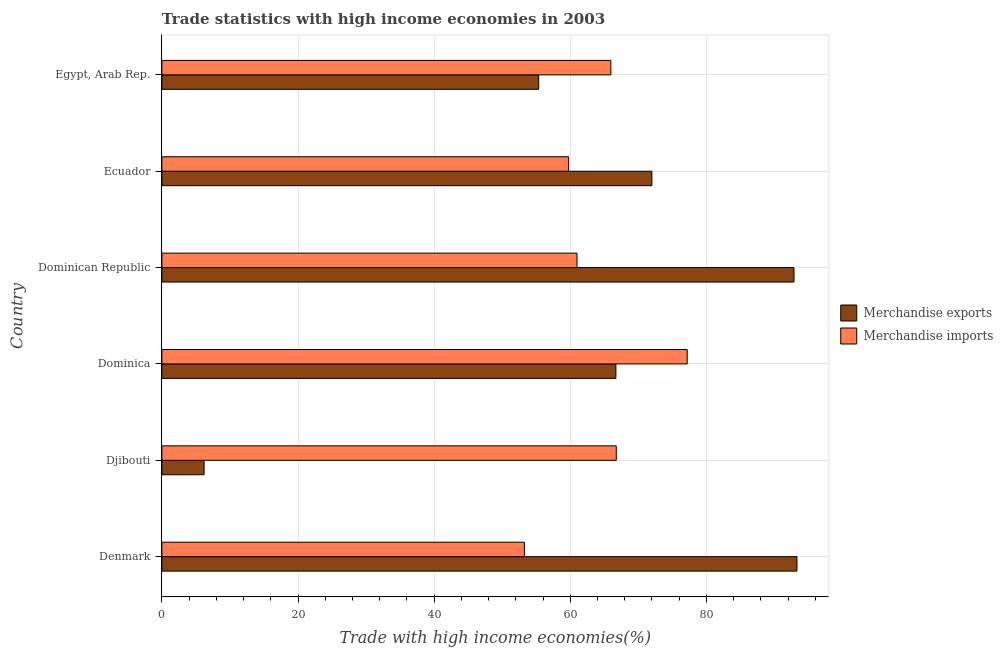How many different coloured bars are there?
Provide a succinct answer. 2. How many groups of bars are there?
Provide a short and direct response. 6. Are the number of bars on each tick of the Y-axis equal?
Keep it short and to the point. Yes. How many bars are there on the 4th tick from the top?
Offer a terse response. 2. What is the label of the 1st group of bars from the top?
Your answer should be compact. Egypt, Arab Rep. What is the merchandise exports in Denmark?
Offer a terse response. 93.31. Across all countries, what is the maximum merchandise exports?
Ensure brevity in your answer.  93.31. Across all countries, what is the minimum merchandise imports?
Offer a terse response. 53.26. In which country was the merchandise imports minimum?
Provide a short and direct response. Denmark. What is the total merchandise exports in the graph?
Provide a succinct answer. 386.44. What is the difference between the merchandise exports in Djibouti and that in Egypt, Arab Rep.?
Give a very brief answer. -49.16. What is the difference between the merchandise imports in Ecuador and the merchandise exports in Denmark?
Ensure brevity in your answer.  -33.55. What is the average merchandise imports per country?
Give a very brief answer. 63.98. What is the difference between the merchandise imports and merchandise exports in Dominica?
Ensure brevity in your answer.  10.48. In how many countries, is the merchandise exports greater than 68 %?
Offer a terse response. 3. What is the ratio of the merchandise imports in Djibouti to that in Ecuador?
Your response must be concise. 1.12. Is the merchandise exports in Dominican Republic less than that in Egypt, Arab Rep.?
Offer a terse response. No. Is the difference between the merchandise exports in Dominica and Dominican Republic greater than the difference between the merchandise imports in Dominica and Dominican Republic?
Provide a succinct answer. No. What is the difference between the highest and the second highest merchandise exports?
Give a very brief answer. 0.44. What is the difference between the highest and the lowest merchandise imports?
Give a very brief answer. 23.92. In how many countries, is the merchandise imports greater than the average merchandise imports taken over all countries?
Your response must be concise. 3. Is the sum of the merchandise imports in Dominican Republic and Ecuador greater than the maximum merchandise exports across all countries?
Your answer should be compact. Yes. What does the 2nd bar from the top in Ecuador represents?
Give a very brief answer. Merchandise exports. How many bars are there?
Your answer should be very brief. 12. How many countries are there in the graph?
Provide a short and direct response. 6. What is the difference between two consecutive major ticks on the X-axis?
Provide a succinct answer. 20. Does the graph contain any zero values?
Offer a very short reply. No. How are the legend labels stacked?
Give a very brief answer. Vertical. What is the title of the graph?
Your answer should be compact. Trade statistics with high income economies in 2003. Does "State government" appear as one of the legend labels in the graph?
Your answer should be very brief. No. What is the label or title of the X-axis?
Your answer should be compact. Trade with high income economies(%). What is the Trade with high income economies(%) in Merchandise exports in Denmark?
Give a very brief answer. 93.31. What is the Trade with high income economies(%) in Merchandise imports in Denmark?
Your response must be concise. 53.26. What is the Trade with high income economies(%) in Merchandise exports in Djibouti?
Provide a short and direct response. 6.2. What is the Trade with high income economies(%) in Merchandise imports in Djibouti?
Your answer should be very brief. 66.76. What is the Trade with high income economies(%) in Merchandise exports in Dominica?
Give a very brief answer. 66.7. What is the Trade with high income economies(%) in Merchandise imports in Dominica?
Your answer should be very brief. 77.18. What is the Trade with high income economies(%) of Merchandise exports in Dominican Republic?
Ensure brevity in your answer.  92.87. What is the Trade with high income economies(%) in Merchandise imports in Dominican Republic?
Provide a succinct answer. 60.99. What is the Trade with high income economies(%) of Merchandise exports in Ecuador?
Your answer should be compact. 71.99. What is the Trade with high income economies(%) in Merchandise imports in Ecuador?
Make the answer very short. 59.76. What is the Trade with high income economies(%) in Merchandise exports in Egypt, Arab Rep.?
Your response must be concise. 55.36. What is the Trade with high income economies(%) in Merchandise imports in Egypt, Arab Rep.?
Offer a terse response. 65.96. Across all countries, what is the maximum Trade with high income economies(%) in Merchandise exports?
Provide a succinct answer. 93.31. Across all countries, what is the maximum Trade with high income economies(%) of Merchandise imports?
Offer a very short reply. 77.18. Across all countries, what is the minimum Trade with high income economies(%) in Merchandise exports?
Ensure brevity in your answer.  6.2. Across all countries, what is the minimum Trade with high income economies(%) in Merchandise imports?
Keep it short and to the point. 53.26. What is the total Trade with high income economies(%) of Merchandise exports in the graph?
Keep it short and to the point. 386.44. What is the total Trade with high income economies(%) in Merchandise imports in the graph?
Offer a very short reply. 383.91. What is the difference between the Trade with high income economies(%) of Merchandise exports in Denmark and that in Djibouti?
Provide a short and direct response. 87.11. What is the difference between the Trade with high income economies(%) in Merchandise imports in Denmark and that in Djibouti?
Provide a short and direct response. -13.5. What is the difference between the Trade with high income economies(%) of Merchandise exports in Denmark and that in Dominica?
Provide a succinct answer. 26.61. What is the difference between the Trade with high income economies(%) of Merchandise imports in Denmark and that in Dominica?
Your answer should be very brief. -23.92. What is the difference between the Trade with high income economies(%) in Merchandise exports in Denmark and that in Dominican Republic?
Make the answer very short. 0.44. What is the difference between the Trade with high income economies(%) of Merchandise imports in Denmark and that in Dominican Republic?
Offer a terse response. -7.73. What is the difference between the Trade with high income economies(%) in Merchandise exports in Denmark and that in Ecuador?
Provide a short and direct response. 21.32. What is the difference between the Trade with high income economies(%) in Merchandise imports in Denmark and that in Ecuador?
Ensure brevity in your answer.  -6.49. What is the difference between the Trade with high income economies(%) of Merchandise exports in Denmark and that in Egypt, Arab Rep.?
Ensure brevity in your answer.  37.94. What is the difference between the Trade with high income economies(%) in Merchandise imports in Denmark and that in Egypt, Arab Rep.?
Offer a terse response. -12.7. What is the difference between the Trade with high income economies(%) of Merchandise exports in Djibouti and that in Dominica?
Your response must be concise. -60.5. What is the difference between the Trade with high income economies(%) of Merchandise imports in Djibouti and that in Dominica?
Keep it short and to the point. -10.42. What is the difference between the Trade with high income economies(%) in Merchandise exports in Djibouti and that in Dominican Republic?
Provide a short and direct response. -86.67. What is the difference between the Trade with high income economies(%) of Merchandise imports in Djibouti and that in Dominican Republic?
Give a very brief answer. 5.77. What is the difference between the Trade with high income economies(%) in Merchandise exports in Djibouti and that in Ecuador?
Give a very brief answer. -65.79. What is the difference between the Trade with high income economies(%) in Merchandise imports in Djibouti and that in Ecuador?
Make the answer very short. 7. What is the difference between the Trade with high income economies(%) in Merchandise exports in Djibouti and that in Egypt, Arab Rep.?
Ensure brevity in your answer.  -49.16. What is the difference between the Trade with high income economies(%) in Merchandise imports in Djibouti and that in Egypt, Arab Rep.?
Your answer should be very brief. 0.8. What is the difference between the Trade with high income economies(%) in Merchandise exports in Dominica and that in Dominican Republic?
Make the answer very short. -26.17. What is the difference between the Trade with high income economies(%) in Merchandise imports in Dominica and that in Dominican Republic?
Ensure brevity in your answer.  16.19. What is the difference between the Trade with high income economies(%) in Merchandise exports in Dominica and that in Ecuador?
Offer a very short reply. -5.29. What is the difference between the Trade with high income economies(%) in Merchandise imports in Dominica and that in Ecuador?
Provide a short and direct response. 17.43. What is the difference between the Trade with high income economies(%) of Merchandise exports in Dominica and that in Egypt, Arab Rep.?
Give a very brief answer. 11.34. What is the difference between the Trade with high income economies(%) in Merchandise imports in Dominica and that in Egypt, Arab Rep.?
Offer a terse response. 11.22. What is the difference between the Trade with high income economies(%) of Merchandise exports in Dominican Republic and that in Ecuador?
Your answer should be very brief. 20.88. What is the difference between the Trade with high income economies(%) in Merchandise imports in Dominican Republic and that in Ecuador?
Provide a short and direct response. 1.23. What is the difference between the Trade with high income economies(%) of Merchandise exports in Dominican Republic and that in Egypt, Arab Rep.?
Your answer should be compact. 37.51. What is the difference between the Trade with high income economies(%) in Merchandise imports in Dominican Republic and that in Egypt, Arab Rep.?
Offer a very short reply. -4.97. What is the difference between the Trade with high income economies(%) in Merchandise exports in Ecuador and that in Egypt, Arab Rep.?
Make the answer very short. 16.63. What is the difference between the Trade with high income economies(%) of Merchandise imports in Ecuador and that in Egypt, Arab Rep.?
Your answer should be compact. -6.21. What is the difference between the Trade with high income economies(%) in Merchandise exports in Denmark and the Trade with high income economies(%) in Merchandise imports in Djibouti?
Provide a succinct answer. 26.55. What is the difference between the Trade with high income economies(%) in Merchandise exports in Denmark and the Trade with high income economies(%) in Merchandise imports in Dominica?
Provide a succinct answer. 16.13. What is the difference between the Trade with high income economies(%) of Merchandise exports in Denmark and the Trade with high income economies(%) of Merchandise imports in Dominican Republic?
Offer a terse response. 32.32. What is the difference between the Trade with high income economies(%) in Merchandise exports in Denmark and the Trade with high income economies(%) in Merchandise imports in Ecuador?
Provide a succinct answer. 33.55. What is the difference between the Trade with high income economies(%) in Merchandise exports in Denmark and the Trade with high income economies(%) in Merchandise imports in Egypt, Arab Rep.?
Make the answer very short. 27.35. What is the difference between the Trade with high income economies(%) in Merchandise exports in Djibouti and the Trade with high income economies(%) in Merchandise imports in Dominica?
Provide a short and direct response. -70.98. What is the difference between the Trade with high income economies(%) in Merchandise exports in Djibouti and the Trade with high income economies(%) in Merchandise imports in Dominican Republic?
Your response must be concise. -54.79. What is the difference between the Trade with high income economies(%) in Merchandise exports in Djibouti and the Trade with high income economies(%) in Merchandise imports in Ecuador?
Offer a very short reply. -53.55. What is the difference between the Trade with high income economies(%) of Merchandise exports in Djibouti and the Trade with high income economies(%) of Merchandise imports in Egypt, Arab Rep.?
Make the answer very short. -59.76. What is the difference between the Trade with high income economies(%) of Merchandise exports in Dominica and the Trade with high income economies(%) of Merchandise imports in Dominican Republic?
Give a very brief answer. 5.72. What is the difference between the Trade with high income economies(%) of Merchandise exports in Dominica and the Trade with high income economies(%) of Merchandise imports in Ecuador?
Provide a succinct answer. 6.95. What is the difference between the Trade with high income economies(%) of Merchandise exports in Dominica and the Trade with high income economies(%) of Merchandise imports in Egypt, Arab Rep.?
Make the answer very short. 0.74. What is the difference between the Trade with high income economies(%) in Merchandise exports in Dominican Republic and the Trade with high income economies(%) in Merchandise imports in Ecuador?
Give a very brief answer. 33.12. What is the difference between the Trade with high income economies(%) of Merchandise exports in Dominican Republic and the Trade with high income economies(%) of Merchandise imports in Egypt, Arab Rep.?
Give a very brief answer. 26.91. What is the difference between the Trade with high income economies(%) in Merchandise exports in Ecuador and the Trade with high income economies(%) in Merchandise imports in Egypt, Arab Rep.?
Provide a short and direct response. 6.03. What is the average Trade with high income economies(%) of Merchandise exports per country?
Ensure brevity in your answer.  64.41. What is the average Trade with high income economies(%) in Merchandise imports per country?
Give a very brief answer. 63.98. What is the difference between the Trade with high income economies(%) of Merchandise exports and Trade with high income economies(%) of Merchandise imports in Denmark?
Your answer should be very brief. 40.05. What is the difference between the Trade with high income economies(%) of Merchandise exports and Trade with high income economies(%) of Merchandise imports in Djibouti?
Keep it short and to the point. -60.56. What is the difference between the Trade with high income economies(%) in Merchandise exports and Trade with high income economies(%) in Merchandise imports in Dominica?
Make the answer very short. -10.48. What is the difference between the Trade with high income economies(%) in Merchandise exports and Trade with high income economies(%) in Merchandise imports in Dominican Republic?
Give a very brief answer. 31.88. What is the difference between the Trade with high income economies(%) in Merchandise exports and Trade with high income economies(%) in Merchandise imports in Ecuador?
Your answer should be very brief. 12.24. What is the difference between the Trade with high income economies(%) of Merchandise exports and Trade with high income economies(%) of Merchandise imports in Egypt, Arab Rep.?
Offer a very short reply. -10.6. What is the ratio of the Trade with high income economies(%) in Merchandise exports in Denmark to that in Djibouti?
Give a very brief answer. 15.05. What is the ratio of the Trade with high income economies(%) in Merchandise imports in Denmark to that in Djibouti?
Make the answer very short. 0.8. What is the ratio of the Trade with high income economies(%) of Merchandise exports in Denmark to that in Dominica?
Provide a succinct answer. 1.4. What is the ratio of the Trade with high income economies(%) in Merchandise imports in Denmark to that in Dominica?
Offer a terse response. 0.69. What is the ratio of the Trade with high income economies(%) of Merchandise exports in Denmark to that in Dominican Republic?
Offer a very short reply. 1. What is the ratio of the Trade with high income economies(%) of Merchandise imports in Denmark to that in Dominican Republic?
Your answer should be very brief. 0.87. What is the ratio of the Trade with high income economies(%) of Merchandise exports in Denmark to that in Ecuador?
Your answer should be very brief. 1.3. What is the ratio of the Trade with high income economies(%) of Merchandise imports in Denmark to that in Ecuador?
Make the answer very short. 0.89. What is the ratio of the Trade with high income economies(%) in Merchandise exports in Denmark to that in Egypt, Arab Rep.?
Ensure brevity in your answer.  1.69. What is the ratio of the Trade with high income economies(%) of Merchandise imports in Denmark to that in Egypt, Arab Rep.?
Your response must be concise. 0.81. What is the ratio of the Trade with high income economies(%) in Merchandise exports in Djibouti to that in Dominica?
Keep it short and to the point. 0.09. What is the ratio of the Trade with high income economies(%) in Merchandise imports in Djibouti to that in Dominica?
Ensure brevity in your answer.  0.86. What is the ratio of the Trade with high income economies(%) in Merchandise exports in Djibouti to that in Dominican Republic?
Provide a succinct answer. 0.07. What is the ratio of the Trade with high income economies(%) of Merchandise imports in Djibouti to that in Dominican Republic?
Your answer should be very brief. 1.09. What is the ratio of the Trade with high income economies(%) of Merchandise exports in Djibouti to that in Ecuador?
Your answer should be very brief. 0.09. What is the ratio of the Trade with high income economies(%) of Merchandise imports in Djibouti to that in Ecuador?
Ensure brevity in your answer.  1.12. What is the ratio of the Trade with high income economies(%) in Merchandise exports in Djibouti to that in Egypt, Arab Rep.?
Offer a terse response. 0.11. What is the ratio of the Trade with high income economies(%) of Merchandise imports in Djibouti to that in Egypt, Arab Rep.?
Your answer should be very brief. 1.01. What is the ratio of the Trade with high income economies(%) in Merchandise exports in Dominica to that in Dominican Republic?
Give a very brief answer. 0.72. What is the ratio of the Trade with high income economies(%) of Merchandise imports in Dominica to that in Dominican Republic?
Your answer should be compact. 1.27. What is the ratio of the Trade with high income economies(%) of Merchandise exports in Dominica to that in Ecuador?
Make the answer very short. 0.93. What is the ratio of the Trade with high income economies(%) of Merchandise imports in Dominica to that in Ecuador?
Your answer should be very brief. 1.29. What is the ratio of the Trade with high income economies(%) in Merchandise exports in Dominica to that in Egypt, Arab Rep.?
Keep it short and to the point. 1.2. What is the ratio of the Trade with high income economies(%) in Merchandise imports in Dominica to that in Egypt, Arab Rep.?
Provide a short and direct response. 1.17. What is the ratio of the Trade with high income economies(%) in Merchandise exports in Dominican Republic to that in Ecuador?
Give a very brief answer. 1.29. What is the ratio of the Trade with high income economies(%) of Merchandise imports in Dominican Republic to that in Ecuador?
Your answer should be compact. 1.02. What is the ratio of the Trade with high income economies(%) of Merchandise exports in Dominican Republic to that in Egypt, Arab Rep.?
Your response must be concise. 1.68. What is the ratio of the Trade with high income economies(%) of Merchandise imports in Dominican Republic to that in Egypt, Arab Rep.?
Give a very brief answer. 0.92. What is the ratio of the Trade with high income economies(%) in Merchandise exports in Ecuador to that in Egypt, Arab Rep.?
Your answer should be very brief. 1.3. What is the ratio of the Trade with high income economies(%) in Merchandise imports in Ecuador to that in Egypt, Arab Rep.?
Give a very brief answer. 0.91. What is the difference between the highest and the second highest Trade with high income economies(%) of Merchandise exports?
Give a very brief answer. 0.44. What is the difference between the highest and the second highest Trade with high income economies(%) of Merchandise imports?
Your answer should be compact. 10.42. What is the difference between the highest and the lowest Trade with high income economies(%) of Merchandise exports?
Offer a terse response. 87.11. What is the difference between the highest and the lowest Trade with high income economies(%) in Merchandise imports?
Make the answer very short. 23.92. 